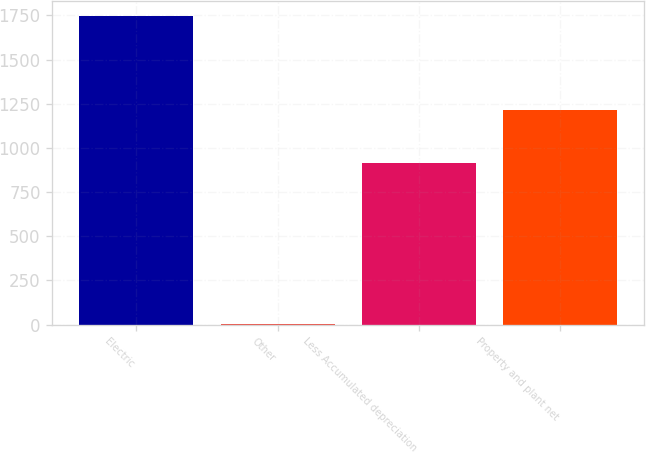<chart> <loc_0><loc_0><loc_500><loc_500><bar_chart><fcel>Electric<fcel>Other<fcel>Less Accumulated depreciation<fcel>Property and plant net<nl><fcel>1744<fcel>6<fcel>915<fcel>1212<nl></chart> 